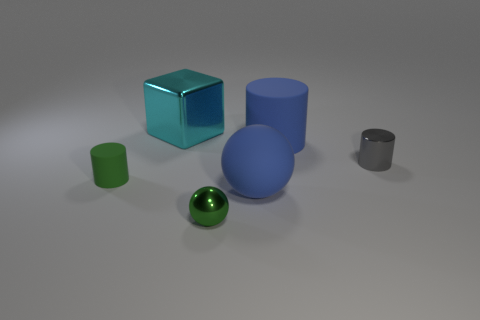What number of objects are big yellow rubber balls or cylinders behind the tiny gray cylinder?
Offer a very short reply. 1. Is the number of big balls on the left side of the big cylinder less than the number of big blue spheres that are to the right of the small gray thing?
Offer a very short reply. No. How many other things are made of the same material as the big blue cylinder?
Ensure brevity in your answer.  2. Do the shiny thing in front of the green matte cylinder and the tiny matte thing have the same color?
Make the answer very short. Yes. There is a big blue rubber object that is in front of the gray shiny cylinder; are there any balls on the left side of it?
Keep it short and to the point. Yes. There is a object that is both to the right of the blue matte sphere and behind the small gray shiny cylinder; what is it made of?
Offer a very short reply. Rubber. What is the shape of the tiny green thing that is made of the same material as the big cyan object?
Ensure brevity in your answer.  Sphere. Are there any other things that are the same shape as the cyan object?
Make the answer very short. No. Is the small object that is to the left of the cyan cube made of the same material as the small green ball?
Your answer should be compact. No. What is the material of the small green object behind the small green metal ball?
Keep it short and to the point. Rubber. 